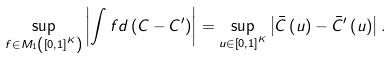Convert formula to latex. <formula><loc_0><loc_0><loc_500><loc_500>\sup _ { f \in M _ { 1 } \left ( \left [ 0 , 1 \right ] ^ { K } \right ) } \left | \int f d \left ( C - C ^ { \prime } \right ) \right | = \sup _ { u \in \left [ 0 , 1 \right ] ^ { K } } \left | \bar { C } \left ( u \right ) - \bar { C } ^ { \prime } \left ( u \right ) \right | .</formula> 